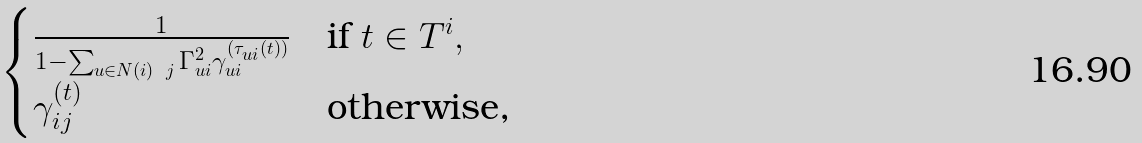<formula> <loc_0><loc_0><loc_500><loc_500>\begin{cases} \frac { 1 } { 1 - \sum _ { u \in N ( i ) \ j } \Gamma _ { u i } ^ { 2 } \gamma ^ { ( \tau _ { u i } ( t ) ) } _ { u i } } & \text {if $t\in T^{i}$} , \\ \gamma ^ { ( t ) } _ { i j } & \text {otherwise,} \end{cases}</formula> 